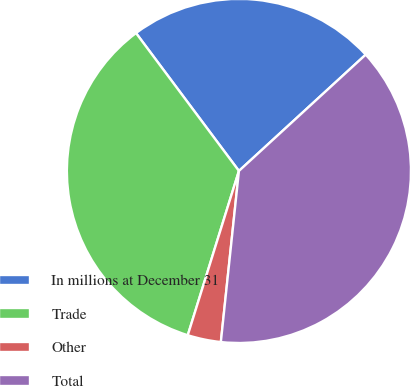Convert chart to OTSL. <chart><loc_0><loc_0><loc_500><loc_500><pie_chart><fcel>In millions at December 31<fcel>Trade<fcel>Other<fcel>Total<nl><fcel>23.39%<fcel>34.99%<fcel>3.13%<fcel>38.49%<nl></chart> 